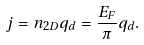Convert formula to latex. <formula><loc_0><loc_0><loc_500><loc_500>j = n _ { 2 D } q _ { d } = \frac { E _ { F } } { \pi } q _ { d } .</formula> 